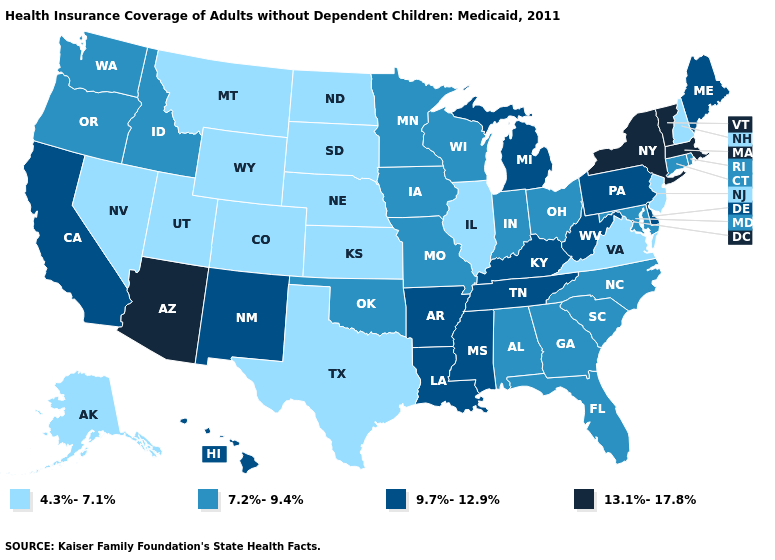Name the states that have a value in the range 4.3%-7.1%?
Short answer required. Alaska, Colorado, Illinois, Kansas, Montana, Nebraska, Nevada, New Hampshire, New Jersey, North Dakota, South Dakota, Texas, Utah, Virginia, Wyoming. What is the lowest value in the Northeast?
Be succinct. 4.3%-7.1%. What is the highest value in states that border Arizona?
Quick response, please. 9.7%-12.9%. What is the value of Georgia?
Quick response, please. 7.2%-9.4%. Name the states that have a value in the range 9.7%-12.9%?
Give a very brief answer. Arkansas, California, Delaware, Hawaii, Kentucky, Louisiana, Maine, Michigan, Mississippi, New Mexico, Pennsylvania, Tennessee, West Virginia. Does the map have missing data?
Give a very brief answer. No. Which states have the lowest value in the South?
Quick response, please. Texas, Virginia. Does Idaho have a lower value than Rhode Island?
Concise answer only. No. What is the value of Idaho?
Quick response, please. 7.2%-9.4%. Does Ohio have the lowest value in the MidWest?
Short answer required. No. Name the states that have a value in the range 13.1%-17.8%?
Keep it brief. Arizona, Massachusetts, New York, Vermont. What is the value of Texas?
Quick response, please. 4.3%-7.1%. Which states hav the highest value in the Northeast?
Answer briefly. Massachusetts, New York, Vermont. What is the lowest value in the MidWest?
Short answer required. 4.3%-7.1%. What is the value of Connecticut?
Answer briefly. 7.2%-9.4%. 